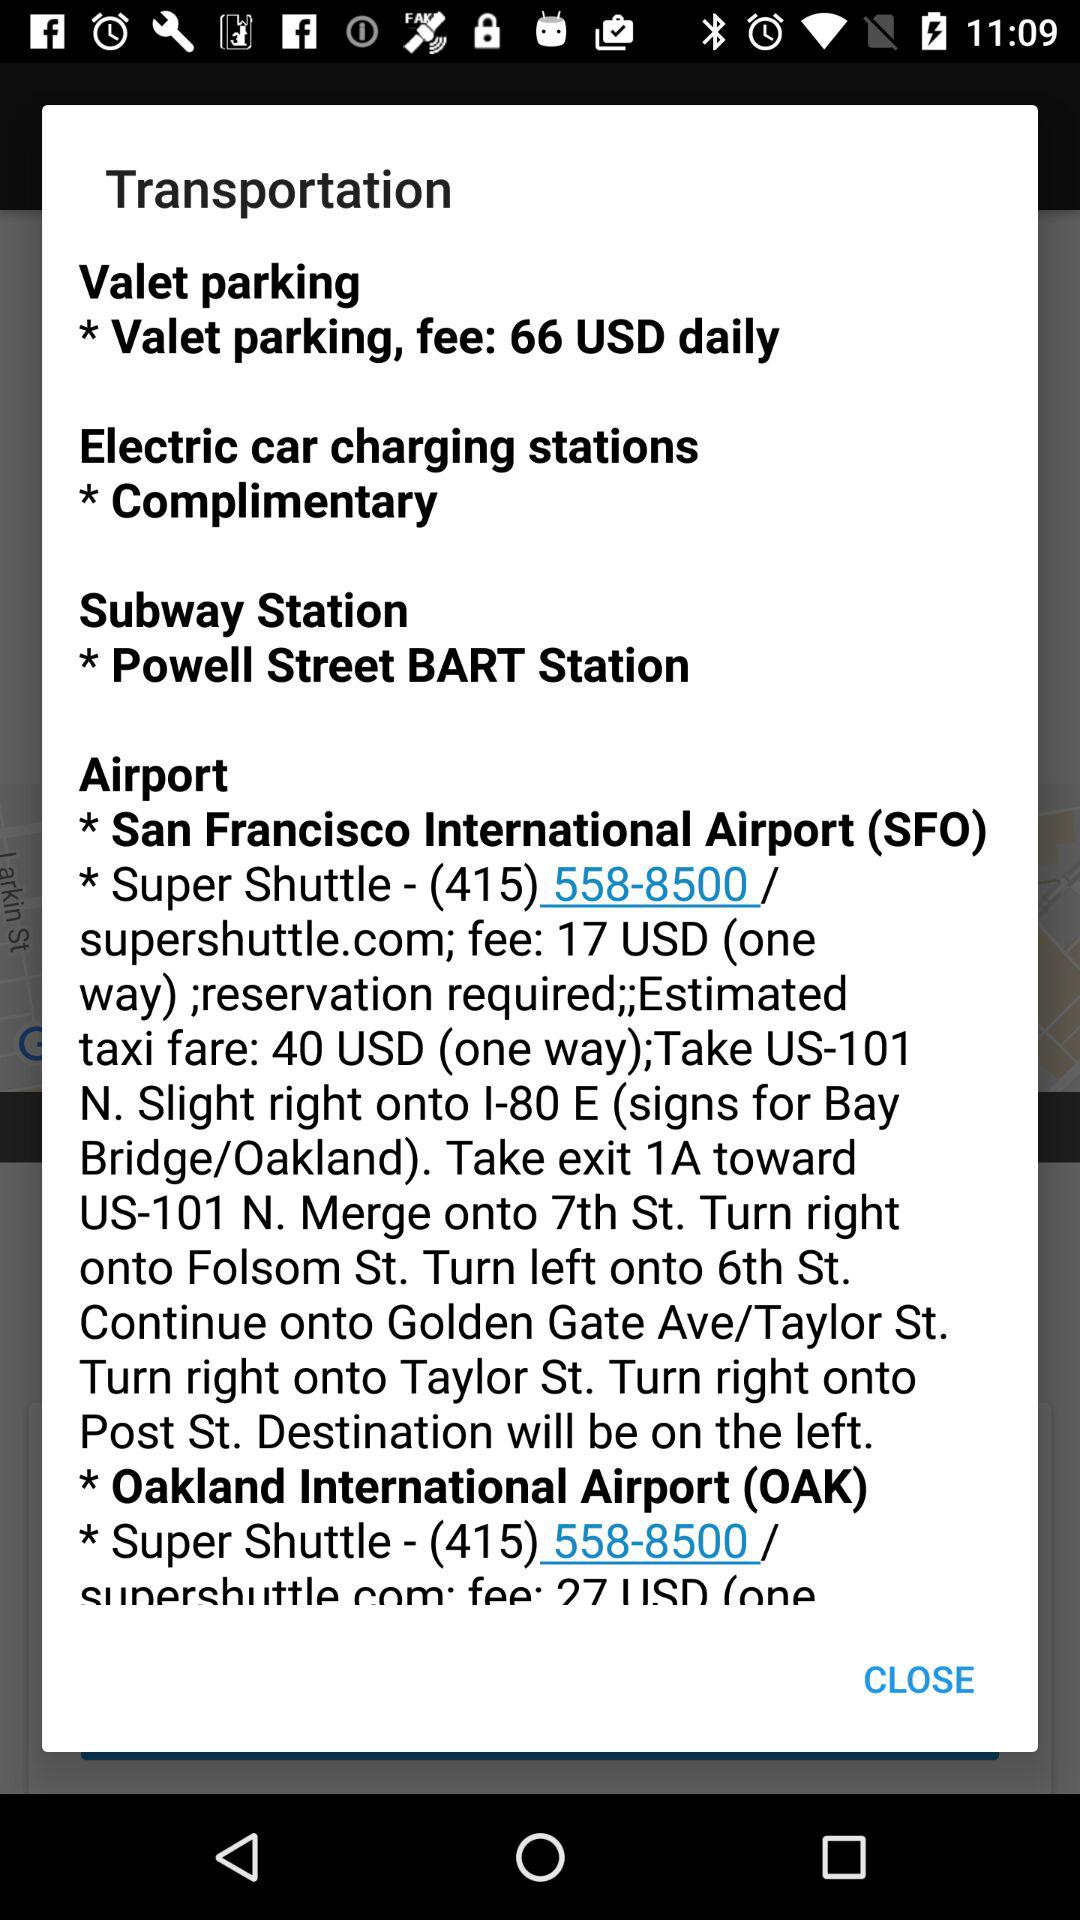What is the web address of the shuttle? The web address is "supershuttle.com". 